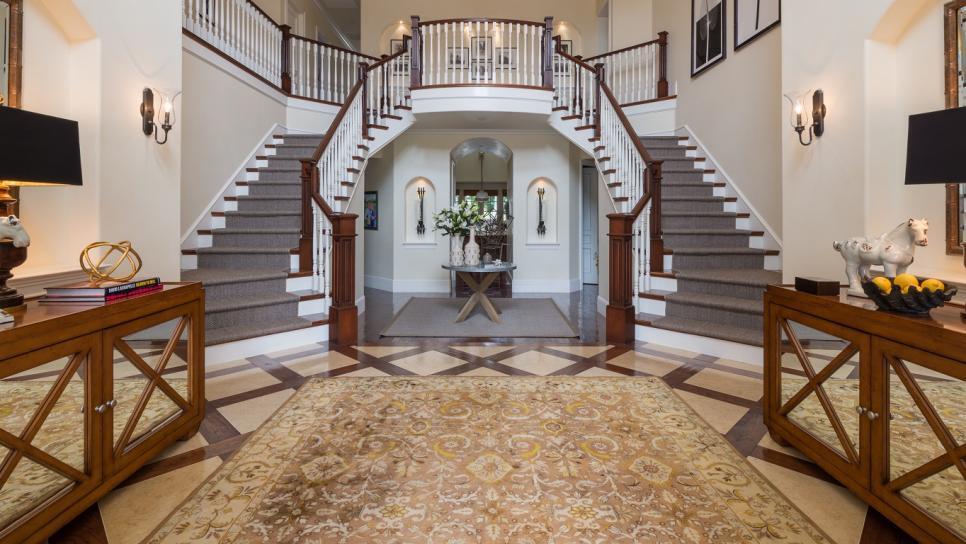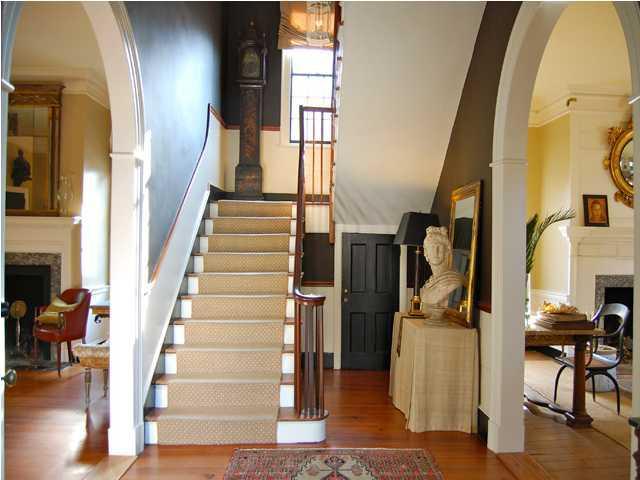The first image is the image on the left, the second image is the image on the right. For the images displayed, is the sentence "One image contains two curved stairways with carpeted steps, white base boards, and brown handrails and balusters, and at least one of the stairways has white spindles." factually correct? Answer yes or no. Yes. The first image is the image on the left, the second image is the image on the right. For the images shown, is this caption "In at least one image there is a flight of stair facing left with a railing that has thin rods spaced out." true? Answer yes or no. No. 